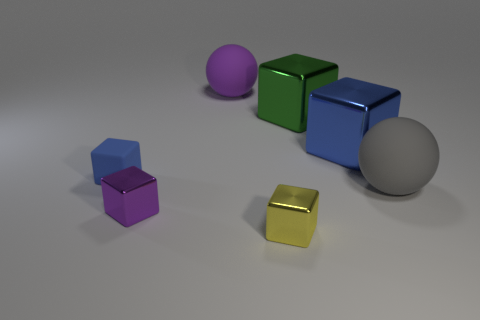Subtract all tiny blue matte cubes. How many cubes are left? 4 Subtract all balls. How many objects are left? 5 Subtract all purple spheres. How many spheres are left? 1 Add 4 large green metallic things. How many large green metallic things are left? 5 Add 4 big yellow matte cubes. How many big yellow matte cubes exist? 4 Add 3 small purple metal cubes. How many objects exist? 10 Subtract 1 gray spheres. How many objects are left? 6 Subtract 1 spheres. How many spheres are left? 1 Subtract all red blocks. Subtract all red spheres. How many blocks are left? 5 Subtract all blue cylinders. How many purple balls are left? 1 